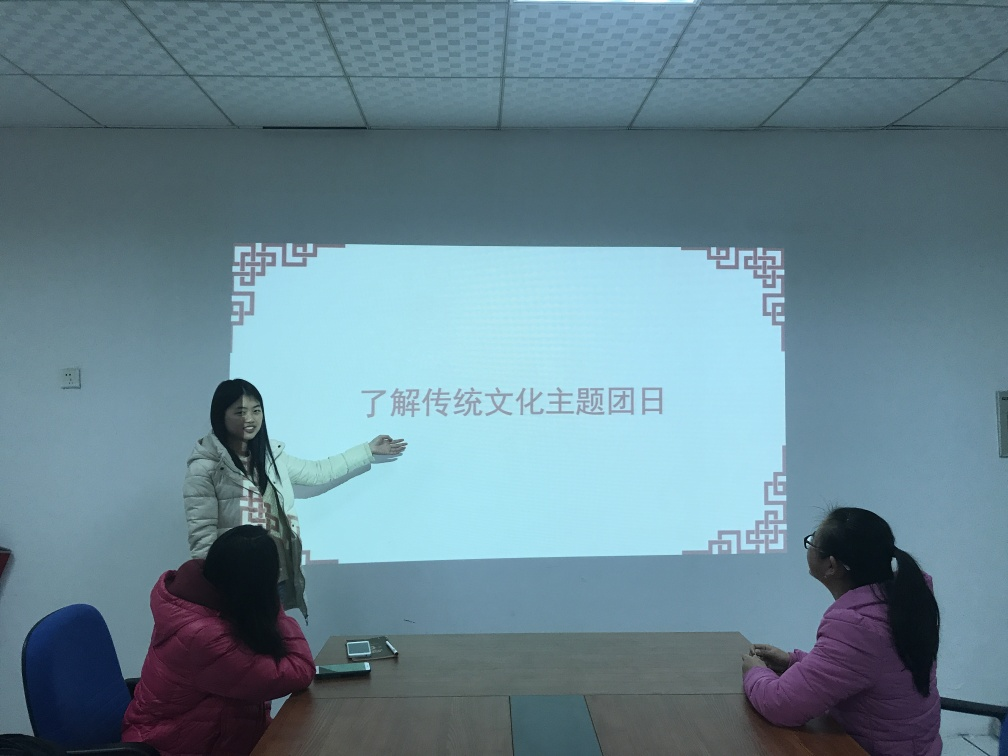Does the image provide any cultural context or clues? Yes, the text on the screen seems to be in Chinese characters, which suggests that the presentation could be taking place in a Chinese-speaking region or involves a Chinese subject matter. The decor also seems simplistic, which might align with certain cultural design preferences or functional spaces within such regions. Is there use of color that tells us something about the mood or atmosphere? The colors in the image are quite muted and consist largely of cool tones. These colors, along with the utilitarian furnishings, may indicate a serious, straightforward atmosphere typical of an academic or professional setting. 